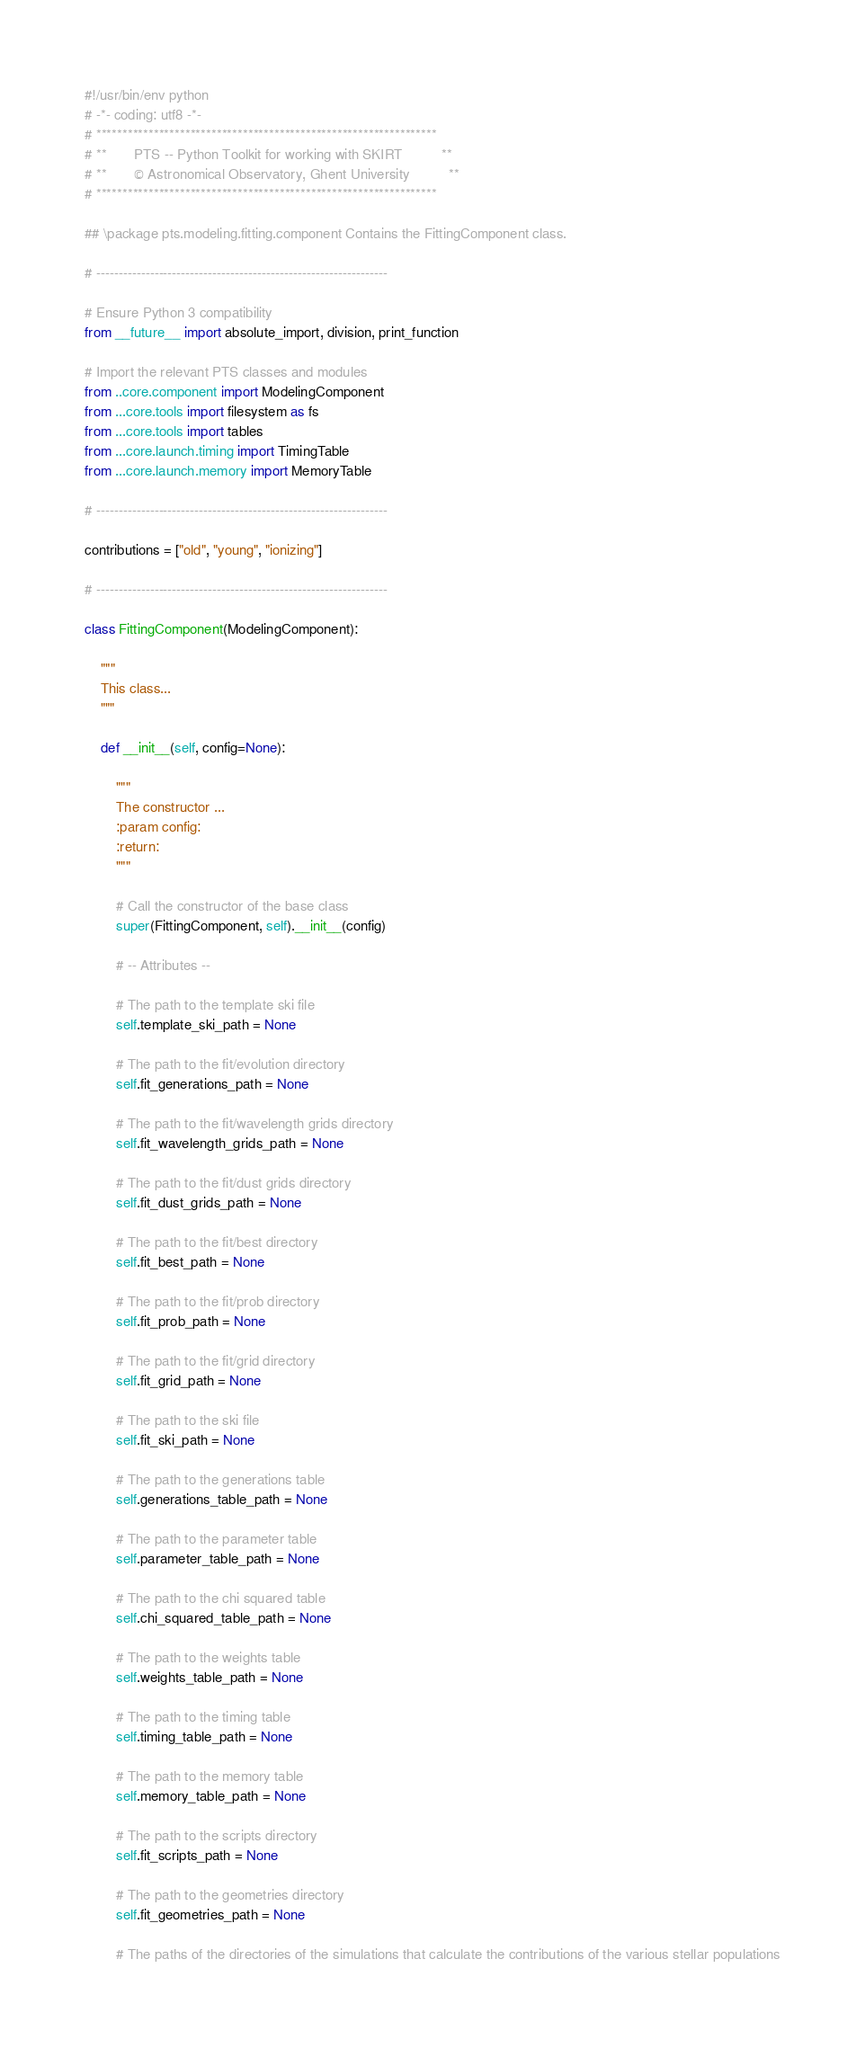Convert code to text. <code><loc_0><loc_0><loc_500><loc_500><_Python_>#!/usr/bin/env python
# -*- coding: utf8 -*-
# *****************************************************************
# **       PTS -- Python Toolkit for working with SKIRT          **
# **       © Astronomical Observatory, Ghent University          **
# *****************************************************************

## \package pts.modeling.fitting.component Contains the FittingComponent class.

# -----------------------------------------------------------------

# Ensure Python 3 compatibility
from __future__ import absolute_import, division, print_function

# Import the relevant PTS classes and modules
from ..core.component import ModelingComponent
from ...core.tools import filesystem as fs
from ...core.tools import tables
from ...core.launch.timing import TimingTable
from ...core.launch.memory import MemoryTable

# -----------------------------------------------------------------

contributions = ["old", "young", "ionizing"]

# -----------------------------------------------------------------

class FittingComponent(ModelingComponent):
    
    """
    This class...
    """

    def __init__(self, config=None):

        """
        The constructor ...
        :param config:
        :return:
        """

        # Call the constructor of the base class
        super(FittingComponent, self).__init__(config)

        # -- Attributes --

        # The path to the template ski file
        self.template_ski_path = None

        # The path to the fit/evolution directory
        self.fit_generations_path = None

        # The path to the fit/wavelength grids directory
        self.fit_wavelength_grids_path = None

        # The path to the fit/dust grids directory
        self.fit_dust_grids_path = None

        # The path to the fit/best directory
        self.fit_best_path = None

        # The path to the fit/prob directory
        self.fit_prob_path = None

        # The path to the fit/grid directory
        self.fit_grid_path = None

        # The path to the ski file
        self.fit_ski_path = None

        # The path to the generations table
        self.generations_table_path = None

        # The path to the parameter table
        self.parameter_table_path = None

        # The path to the chi squared table
        self.chi_squared_table_path = None

        # The path to the weights table
        self.weights_table_path = None

        # The path to the timing table
        self.timing_table_path = None

        # The path to the memory table
        self.memory_table_path = None

        # The path to the scripts directory
        self.fit_scripts_path = None

        # The path to the geometries directory
        self.fit_geometries_path = None

        # The paths of the directories of the simulations that calculate the contributions of the various stellar populations</code> 